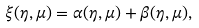Convert formula to latex. <formula><loc_0><loc_0><loc_500><loc_500>\xi ( \eta , \mu ) = \alpha ( \eta , \mu ) + \beta ( \eta , \mu ) ,</formula> 